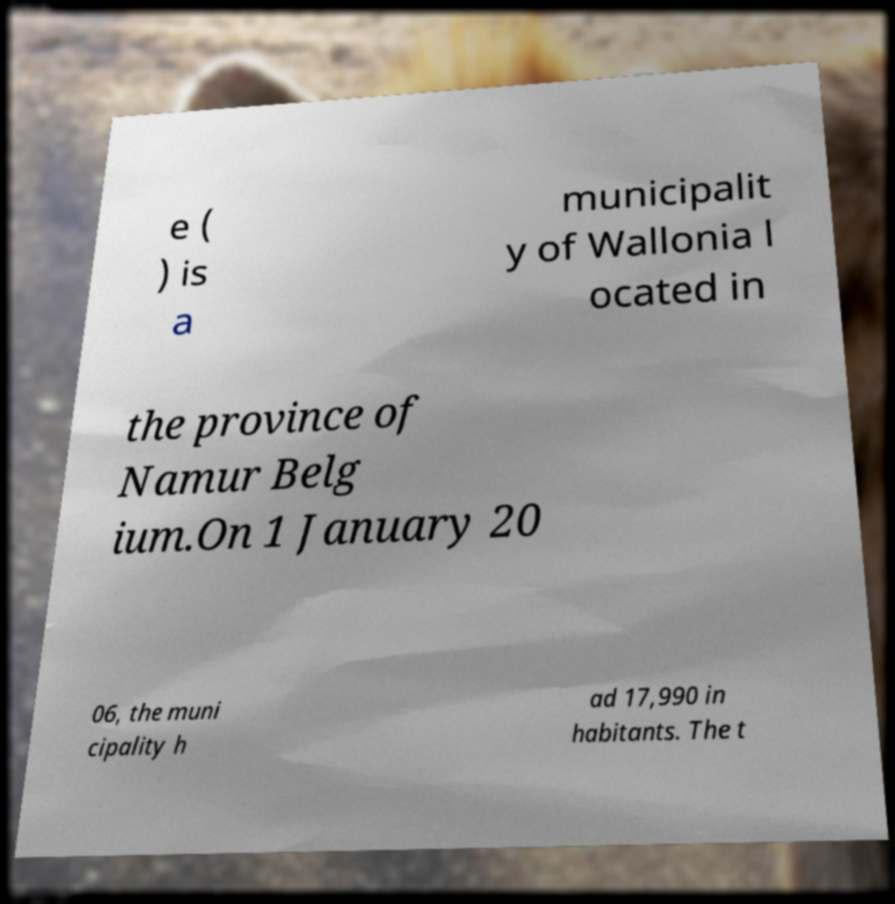I need the written content from this picture converted into text. Can you do that? e ( ) is a municipalit y of Wallonia l ocated in the province of Namur Belg ium.On 1 January 20 06, the muni cipality h ad 17,990 in habitants. The t 